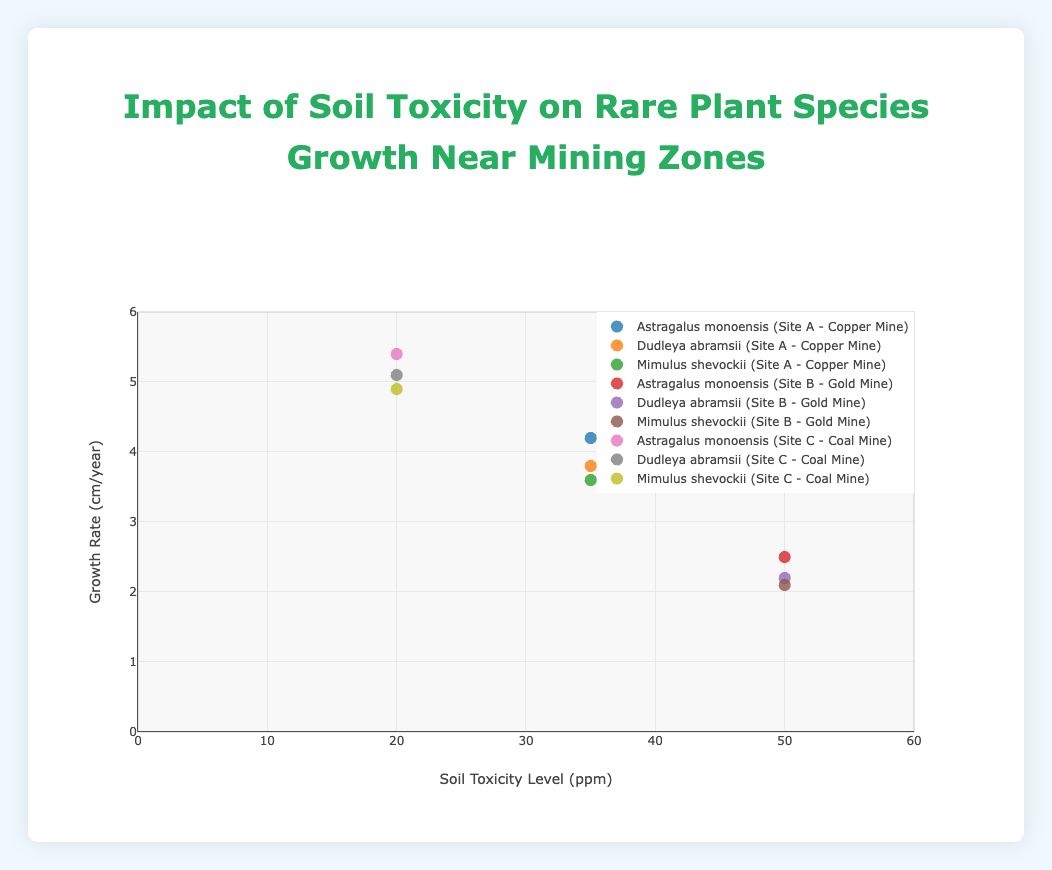What's the highest growth rate observed in the figure? To determine the highest growth rate, look for the highest point on the y-axis (Growth Rate (cm/year)). The highest value is 5.4 cm/year for the species "Astragalus monoensis" at Site C - Coal Mine.
Answer: 5.4 cm/year How does the growth rate for Mimulus shevockii differ between Site A and Site C? The growth rate for Mimulus shevockii at Site A (Copper Mine) is 3.6 cm/year and at Site C (Coal Mine) is 4.9 cm/year. Subtract the growth rate at Site A from the growth rate at Site C: 4.9 - 3.6 = 1.3 cm/year.
Answer: 1.3 cm/year What is the average soil toxicity level at all sites? Add the soil toxicity levels at all sites and then divide by the number of data points. (35 + 35 + 35 + 50 + 50 + 50 + 20 + 20 + 20) / 9 = 35 ppm.
Answer: 35 ppm Which species shows the most significant decrease in growth rate when moving from Site C (Coal Mine, 20 ppm) to Site B (Gold Mine, 50 ppm)? Calculate the decrease for each species: Astragalus monoensis (5.4 - 2.5 = 2.9 cm/year), Dudleya abramsii (5.1 - 2.2 = 2.9 cm/year), Mimulus shevockii (4.9 - 2.1 = 2.8 cm/year).
Answer: Astragalus monoensis and Dudleya abramsii both have the most significant decrease of 2.9 cm/year What is the relationship between soil toxicity levels and growth rates? Observing the scatter plot, as the soil toxicity level increases, the growth rate generally decreases across all species and locations. Higher soil toxicity correlates with reduced plant growth rates.
Answer: Higher soil toxicity correlates with reduced growth rates Is there any location where all species have the same soil toxicity level? Check the soil toxicity levels across different locations for each species. At Site A - Copper Mine, all species have a soil toxicity level of 35 ppm.
Answer: Yes, Site A - Copper Mine (35 ppm for all species) How does Dudleya abramsii's growth rate at Site A compare to its growth rates at Sites B and C? The growth rates of Dudleya abramsii are 3.8 cm/year (Site A), 2.2 cm/year (Site B), and 5.1 cm/year (Site C). Clearly, it grows faster at Site C and slower at Site B compared to Site A.
Answer: Faster at Site C, slower at Site B Which site has the lowest average growth rate across all species? Compute the average growth rate for each site: Site A (4.2 + 3.8 + 3.6)/3 = 3.87 cm/year, Site B (2.5 + 2.2 + 2.1)/3 = 2.27 cm/year, Site C (5.4 + 5.1 + 4.9)/3 = 5.13 cm/year. Site B has the lowest average growth rate of 2.27 cm/year.
Answer: Site B - Gold Mine (2.27 cm/year) 